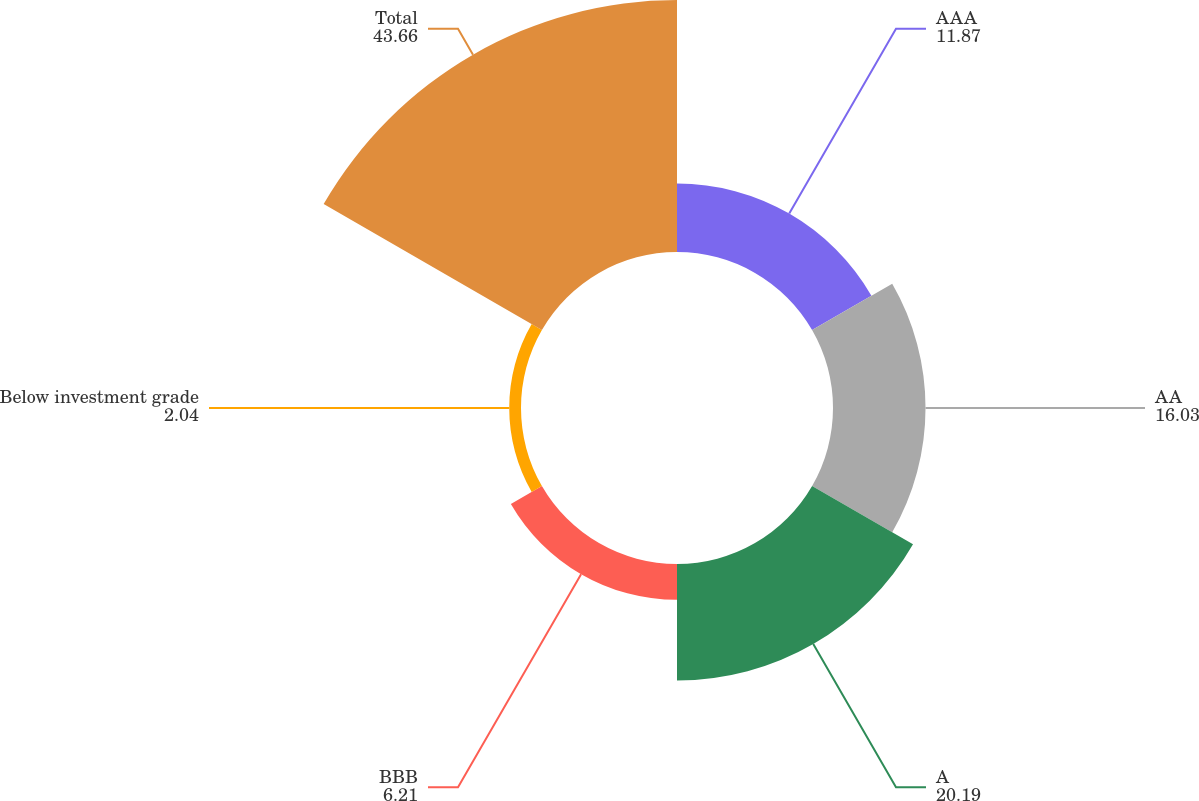Convert chart. <chart><loc_0><loc_0><loc_500><loc_500><pie_chart><fcel>AAA<fcel>AA<fcel>A<fcel>BBB<fcel>Below investment grade<fcel>Total<nl><fcel>11.87%<fcel>16.03%<fcel>20.19%<fcel>6.21%<fcel>2.04%<fcel>43.66%<nl></chart> 